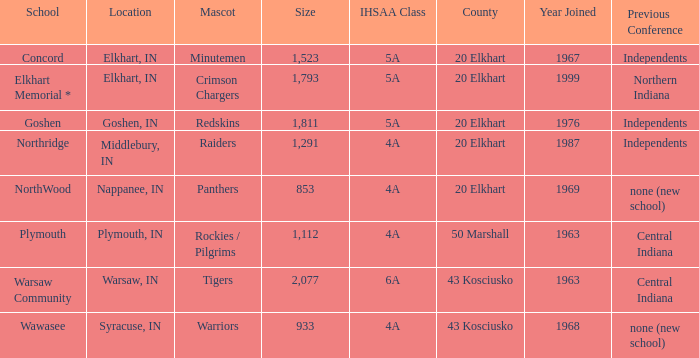What country joined before 1976, with IHSSA class of 5a, and a size larger than 1,112? 20 Elkhart. 